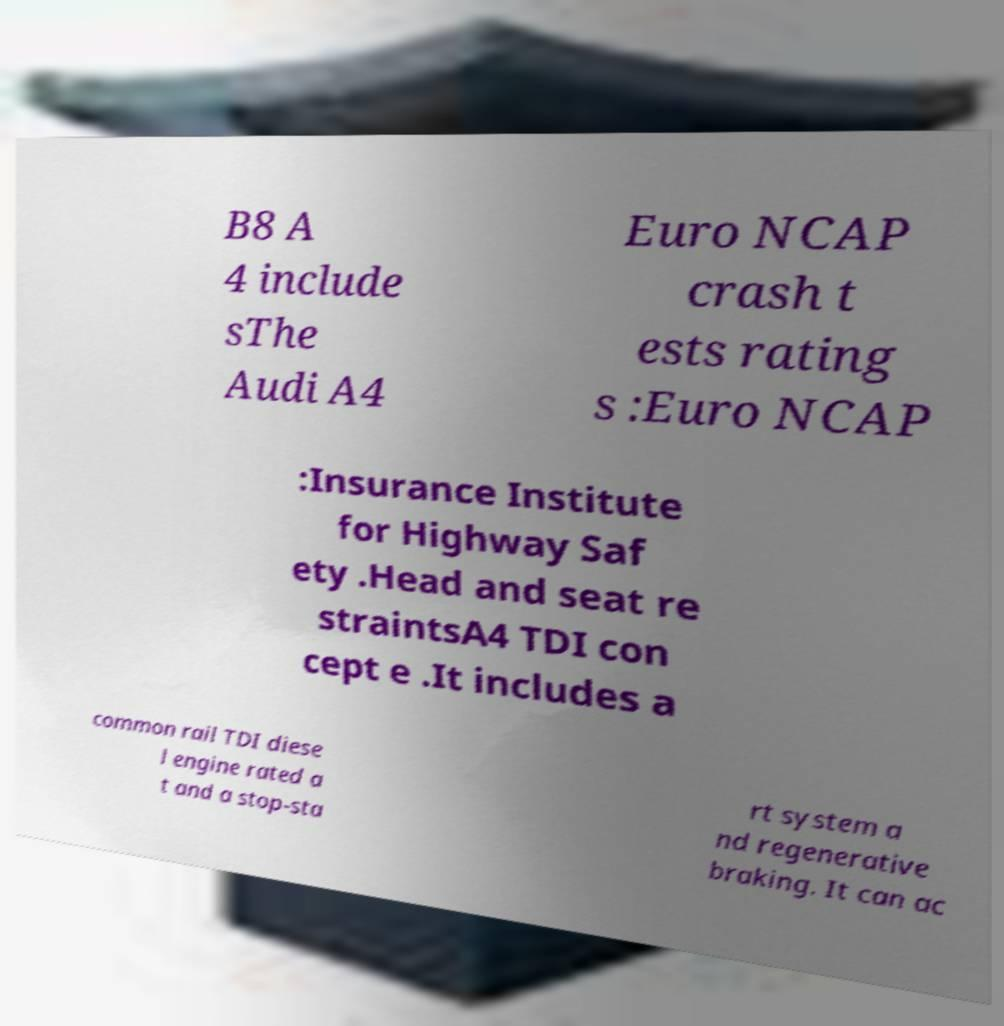Could you assist in decoding the text presented in this image and type it out clearly? B8 A 4 include sThe Audi A4 Euro NCAP crash t ests rating s :Euro NCAP :Insurance Institute for Highway Saf ety .Head and seat re straintsA4 TDI con cept e .It includes a common rail TDI diese l engine rated a t and a stop-sta rt system a nd regenerative braking. It can ac 